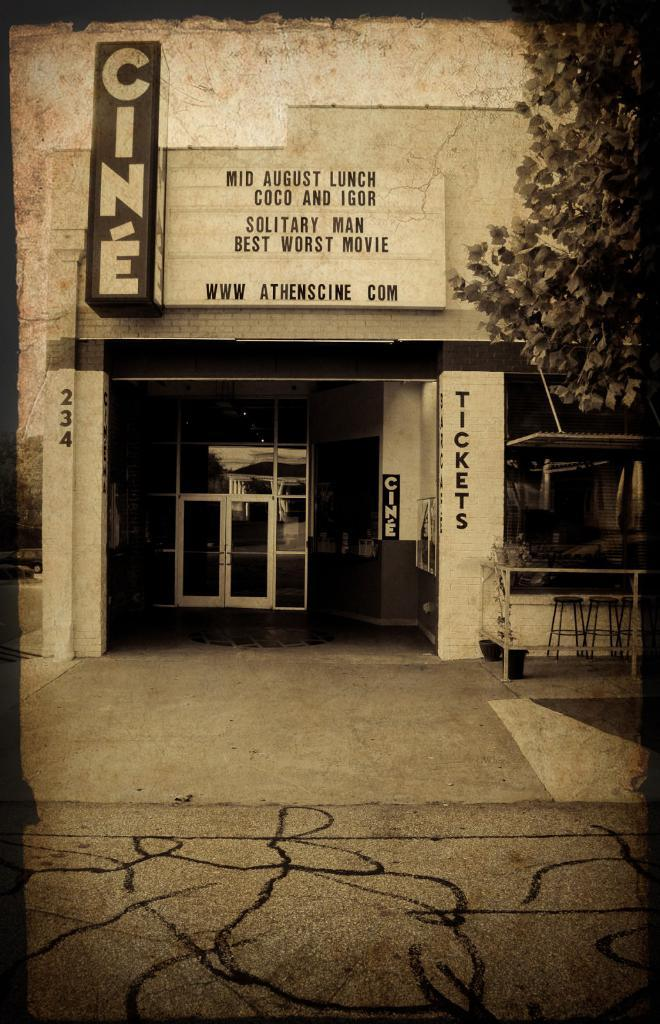What is the main structure in the center of the image? There is a building in the center of the image. What is attached to the building? There is a board on the building. Is there an entrance visible in the image? Yes, there is a door in the image. What can be seen at the bottom of the image? There is a road at the bottom of the image. What type of vegetation is on the right side of the image? There is a tree on the right side of the image. What type of ray is emitted from the building in the image? There is no ray emitted from the building in the image. What kind of party is happening inside the building in the image? There is no indication of a party happening inside the building in the image. 